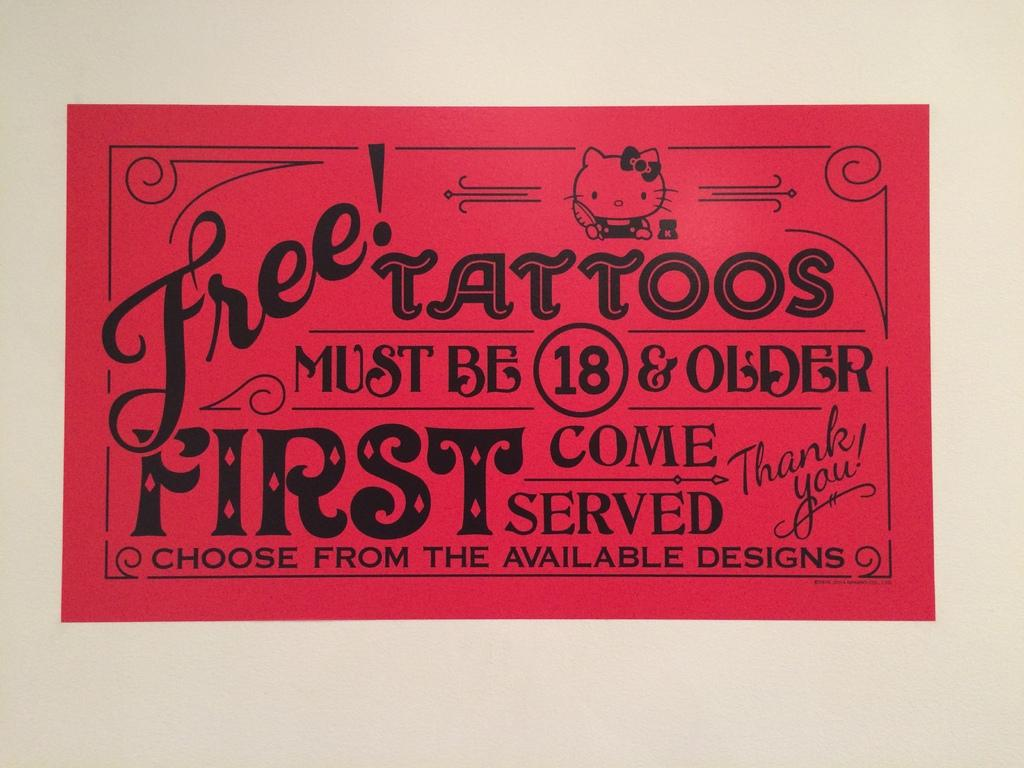What is present on the wall in the image? There is a poster on the wall in the image. What message does the poster convey? The poster contains the words "thank you." What type of silk fabric is draped over the cart in the image? There is no silk fabric or cart present in the image; it only features a poster on a wall. 